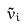Convert formula to latex. <formula><loc_0><loc_0><loc_500><loc_500>\tilde { v } _ { i }</formula> 